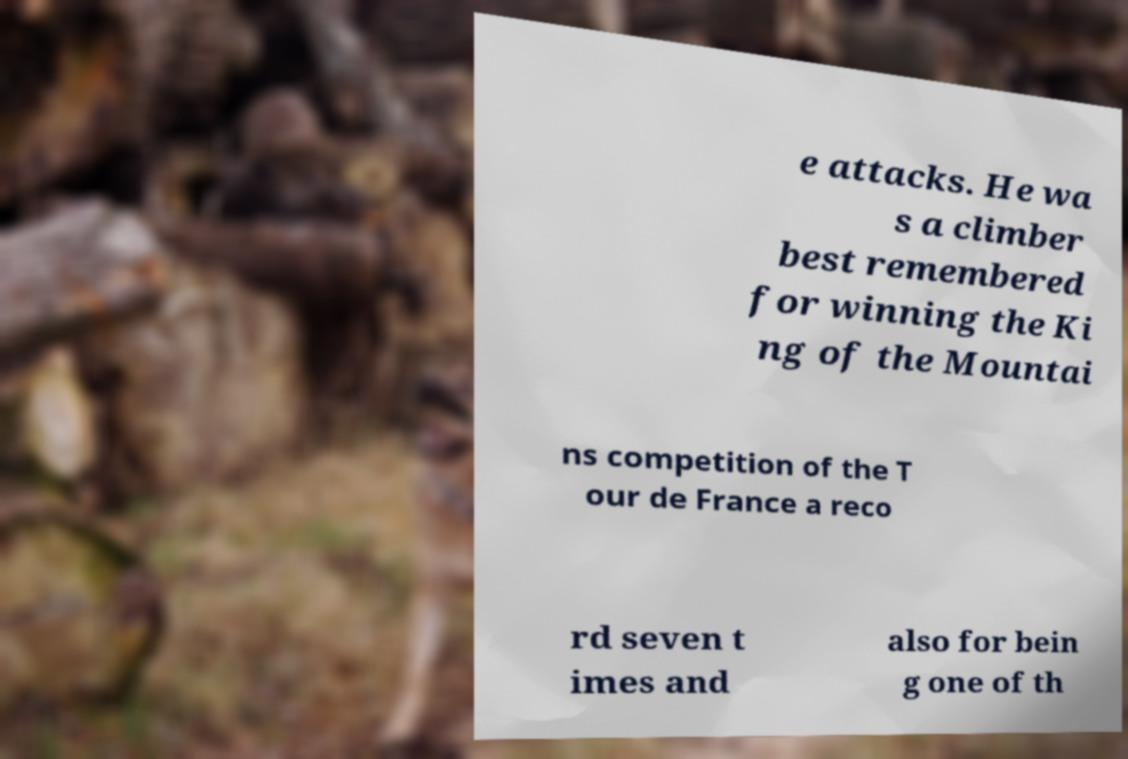Could you assist in decoding the text presented in this image and type it out clearly? e attacks. He wa s a climber best remembered for winning the Ki ng of the Mountai ns competition of the T our de France a reco rd seven t imes and also for bein g one of th 